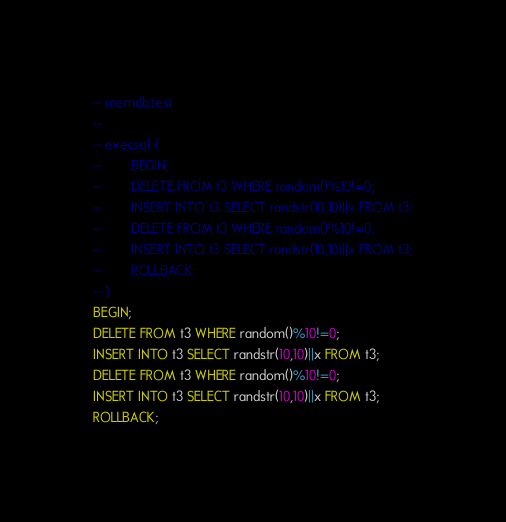<code> <loc_0><loc_0><loc_500><loc_500><_SQL_>-- memdb.test
-- 
-- execsql {
--        BEGIN;
--        DELETE FROM t3 WHERE random()%10!=0;
--        INSERT INTO t3 SELECT randstr(10,10)||x FROM t3;
--        DELETE FROM t3 WHERE random()%10!=0;
--        INSERT INTO t3 SELECT randstr(10,10)||x FROM t3;
--        ROLLBACK;
-- }
BEGIN;
DELETE FROM t3 WHERE random()%10!=0;
INSERT INTO t3 SELECT randstr(10,10)||x FROM t3;
DELETE FROM t3 WHERE random()%10!=0;
INSERT INTO t3 SELECT randstr(10,10)||x FROM t3;
ROLLBACK;</code> 